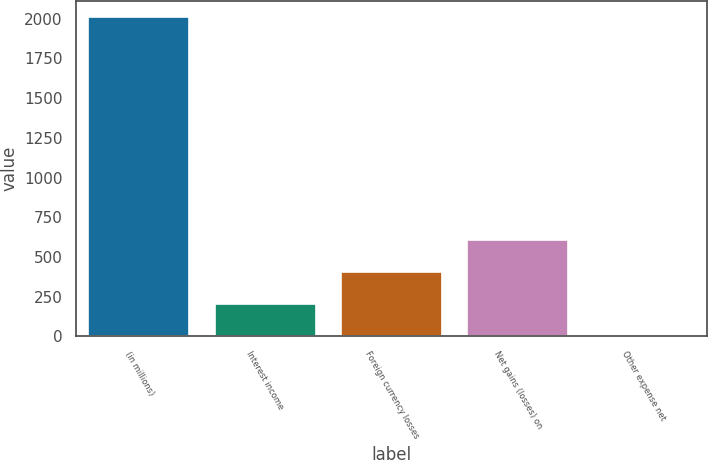<chart> <loc_0><loc_0><loc_500><loc_500><bar_chart><fcel>(in millions)<fcel>Interest income<fcel>Foreign currency losses<fcel>Net gains (losses) on<fcel>Other expense net<nl><fcel>2012<fcel>203<fcel>404<fcel>605<fcel>2<nl></chart> 